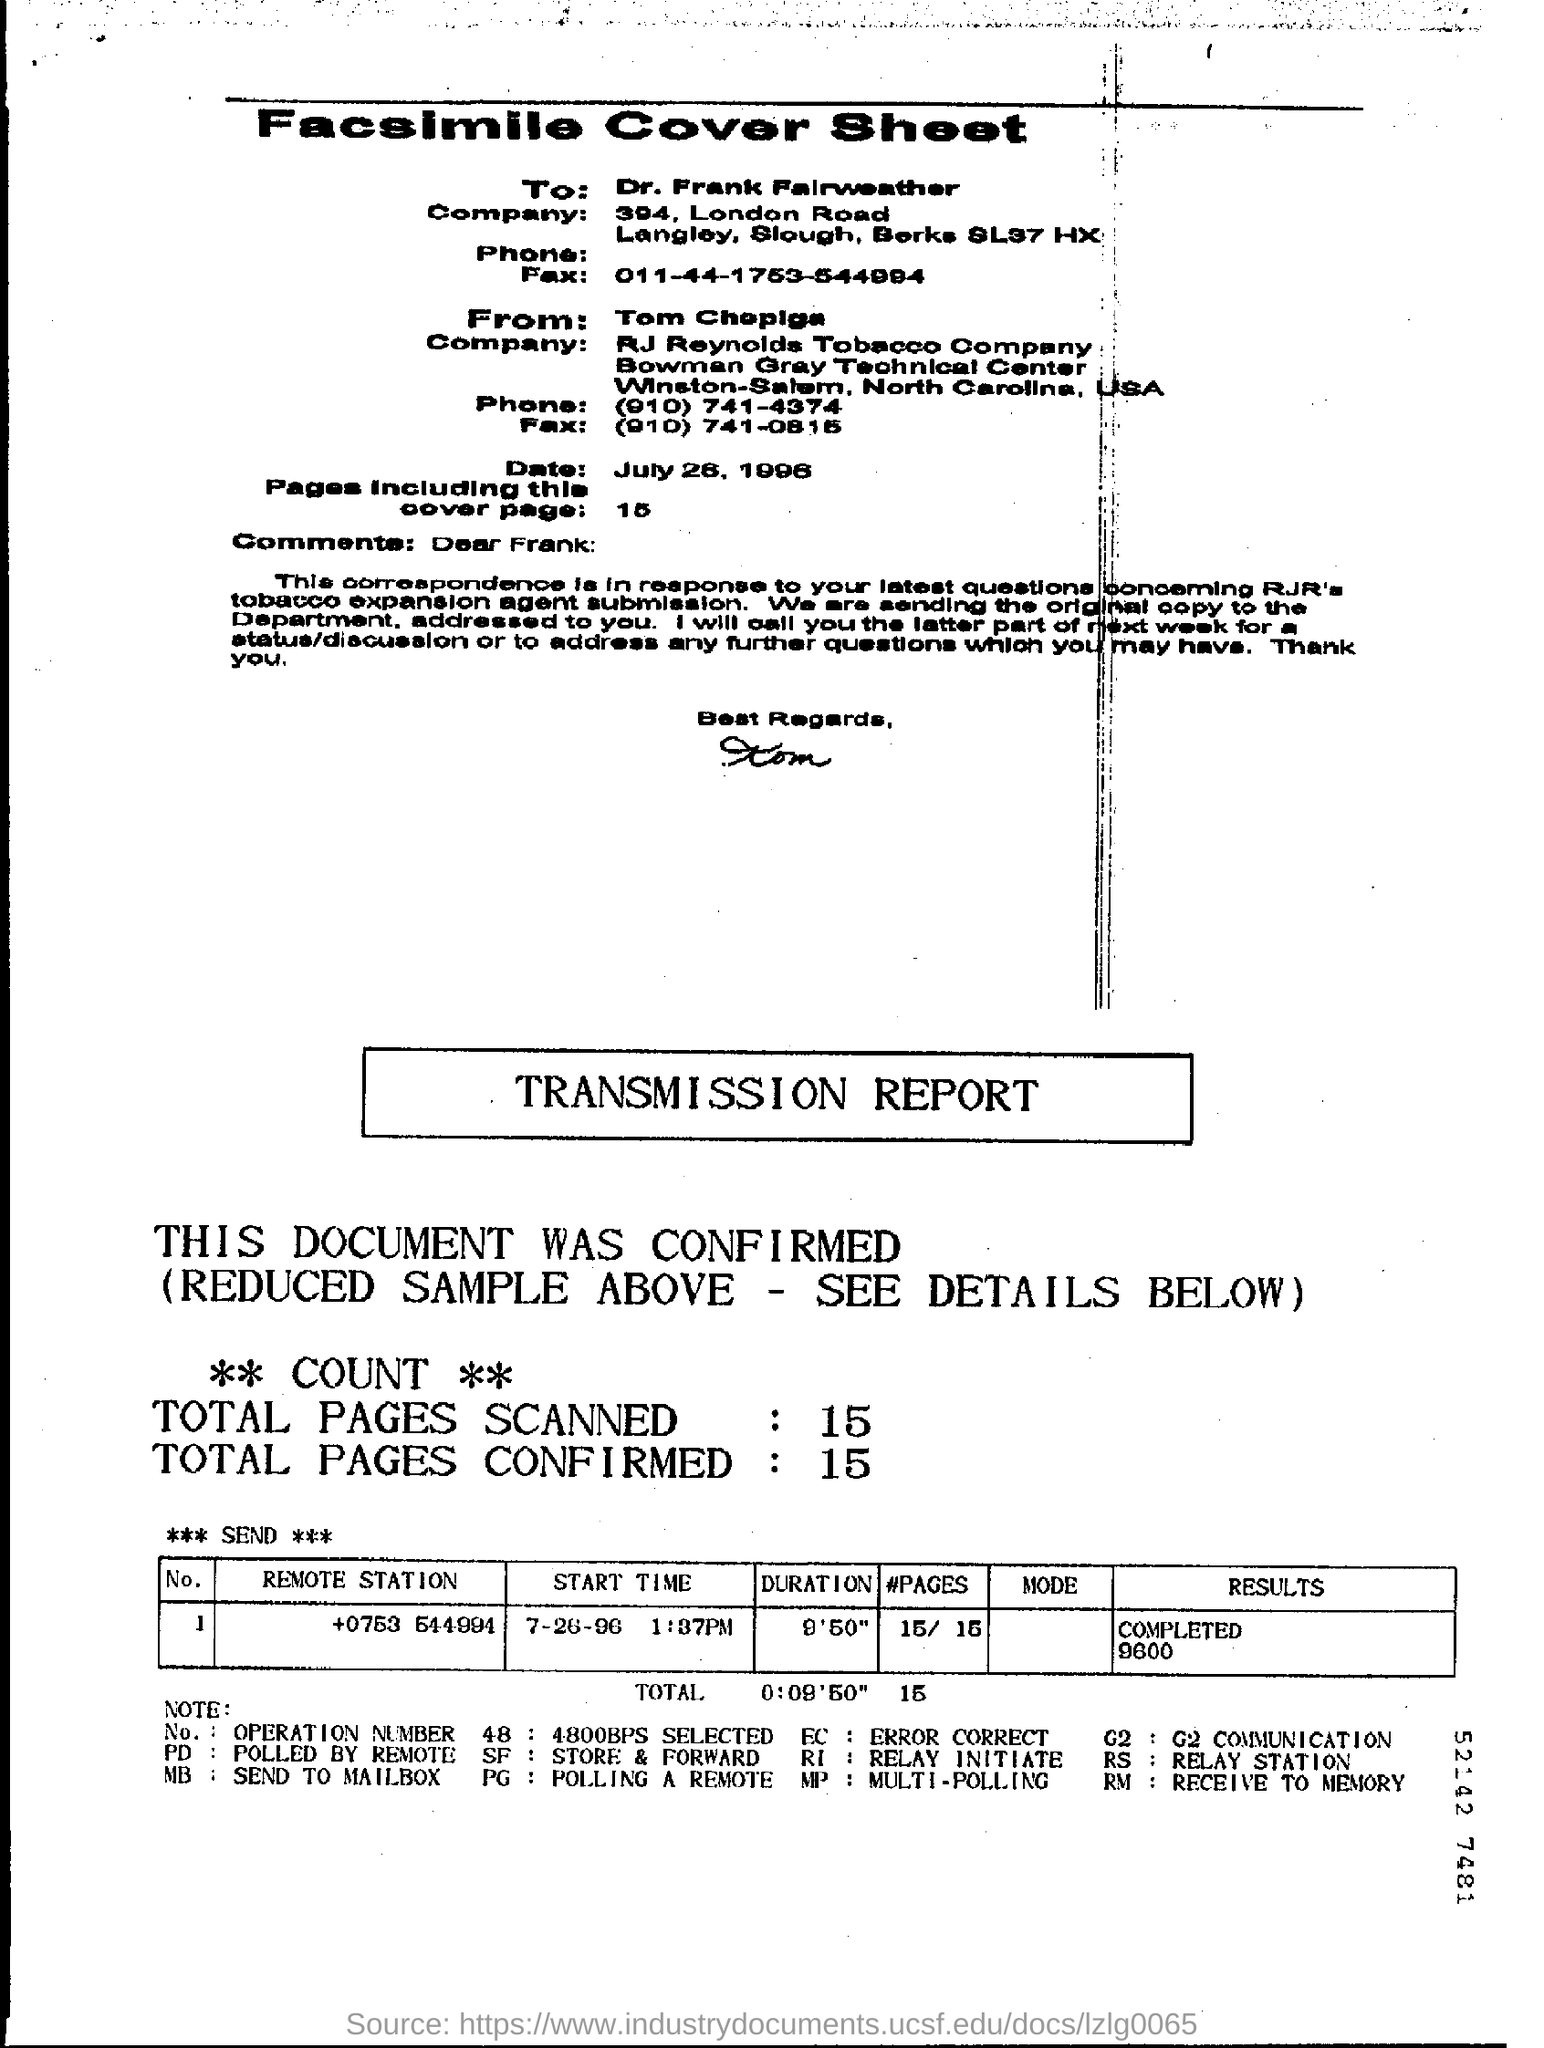Specify some key components in this picture. The cover sheet mentions 15 pages. The start time for sending the pages is July 26, 1996 at 1:37 PM. The addressee is Dr. Frank Falrweather. The notation "PD" refers to polling done remotely, as indicated in the note at the bottom of the page. RI" is an abbreviation that stands for "Relay Initiate," as indicated in the note provided at the bottom of the page. 